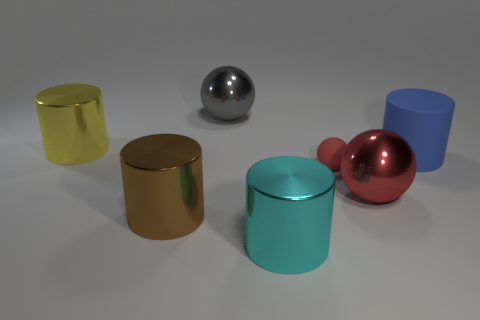The big thing that is the same color as the tiny matte ball is what shape? The larger object that shares the same hue as the small matte ball in the image is a cylinder. 